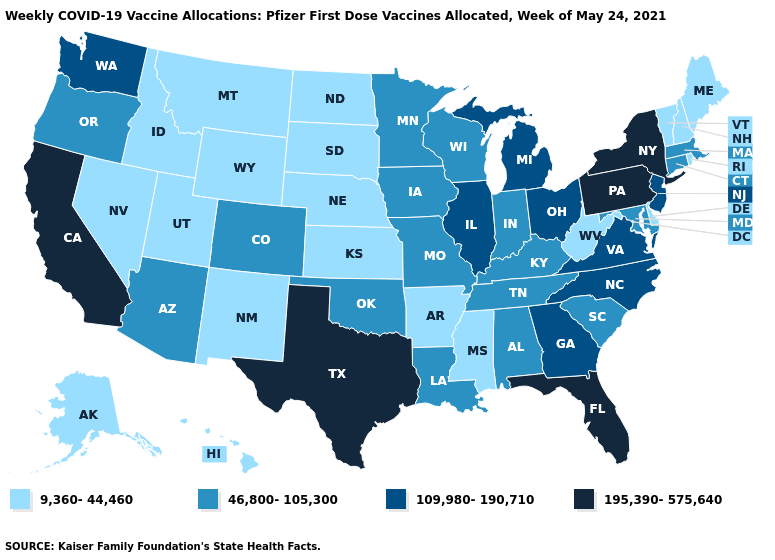Among the states that border South Dakota , which have the highest value?
Quick response, please. Iowa, Minnesota. Name the states that have a value in the range 9,360-44,460?
Give a very brief answer. Alaska, Arkansas, Delaware, Hawaii, Idaho, Kansas, Maine, Mississippi, Montana, Nebraska, Nevada, New Hampshire, New Mexico, North Dakota, Rhode Island, South Dakota, Utah, Vermont, West Virginia, Wyoming. Name the states that have a value in the range 9,360-44,460?
Concise answer only. Alaska, Arkansas, Delaware, Hawaii, Idaho, Kansas, Maine, Mississippi, Montana, Nebraska, Nevada, New Hampshire, New Mexico, North Dakota, Rhode Island, South Dakota, Utah, Vermont, West Virginia, Wyoming. What is the value of North Dakota?
Write a very short answer. 9,360-44,460. What is the lowest value in the South?
Write a very short answer. 9,360-44,460. Which states have the lowest value in the USA?
Be succinct. Alaska, Arkansas, Delaware, Hawaii, Idaho, Kansas, Maine, Mississippi, Montana, Nebraska, Nevada, New Hampshire, New Mexico, North Dakota, Rhode Island, South Dakota, Utah, Vermont, West Virginia, Wyoming. Among the states that border Idaho , does Oregon have the lowest value?
Answer briefly. No. What is the lowest value in the USA?
Short answer required. 9,360-44,460. Name the states that have a value in the range 195,390-575,640?
Be succinct. California, Florida, New York, Pennsylvania, Texas. Name the states that have a value in the range 195,390-575,640?
Write a very short answer. California, Florida, New York, Pennsylvania, Texas. What is the lowest value in the USA?
Concise answer only. 9,360-44,460. What is the value of New Jersey?
Answer briefly. 109,980-190,710. Does Oklahoma have a higher value than Missouri?
Answer briefly. No. What is the value of Texas?
Keep it brief. 195,390-575,640. Which states have the lowest value in the MidWest?
Be succinct. Kansas, Nebraska, North Dakota, South Dakota. 